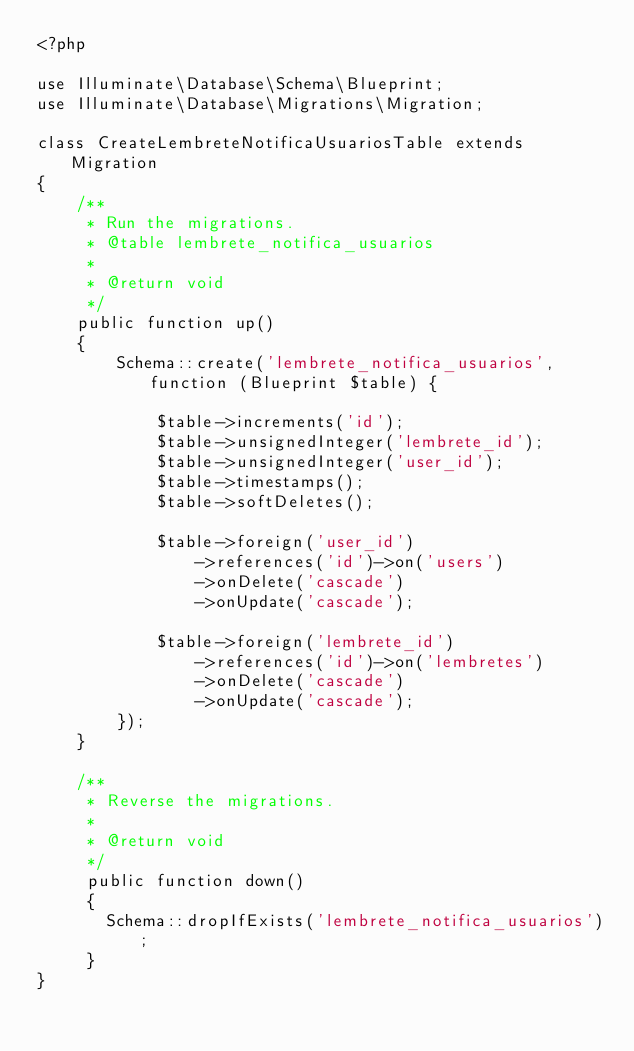Convert code to text. <code><loc_0><loc_0><loc_500><loc_500><_PHP_><?php

use Illuminate\Database\Schema\Blueprint;
use Illuminate\Database\Migrations\Migration;

class CreateLembreteNotificaUsuariosTable extends Migration
{
    /**
     * Run the migrations.
     * @table lembrete_notifica_usuarios
     *
     * @return void
     */
    public function up()
    {
        Schema::create('lembrete_notifica_usuarios', function (Blueprint $table) {
            
            $table->increments('id');
            $table->unsignedInteger('lembrete_id');
            $table->unsignedInteger('user_id');
            $table->timestamps();
            $table->softDeletes();

            $table->foreign('user_id')
                ->references('id')->on('users')
                ->onDelete('cascade')
                ->onUpdate('cascade');

            $table->foreign('lembrete_id')
                ->references('id')->on('lembretes')
                ->onDelete('cascade')
                ->onUpdate('cascade');
        });
    }

    /**
     * Reverse the migrations.
     *
     * @return void
     */
     public function down()
     {
       Schema::dropIfExists('lembrete_notifica_usuarios');
     }
}
</code> 